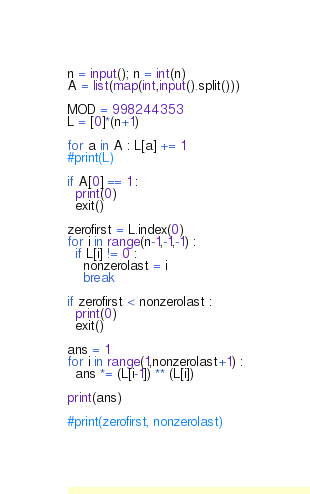<code> <loc_0><loc_0><loc_500><loc_500><_Python_>n = input(); n = int(n)
A = list(map(int,input().split()))

MOD = 998244353
L = [0]*(n+1)

for a in A : L[a] += 1
#print(L)
  
if A[0] == 1 :
  print(0)
  exit()

zerofirst = L.index(0)
for i in range(n-1,-1,-1) :
  if L[i] != 0 :
    nonzerolast = i
    break

if zerofirst < nonzerolast :
  print(0)
  exit()

ans = 1
for i in range(1,nonzerolast+1) :
  ans *= (L[i-1]) ** (L[i])

print(ans)

#print(zerofirst, nonzerolast)

</code> 